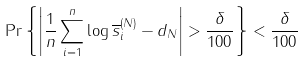Convert formula to latex. <formula><loc_0><loc_0><loc_500><loc_500>\Pr \left \{ \left | \frac { 1 } { n } \sum _ { i = 1 } ^ { n } \log \overline { s } _ { i } ^ { ( N ) } - d _ { N } \right | > \frac { \delta } { 1 0 0 } \right \} < \frac { \delta } { 1 0 0 }</formula> 